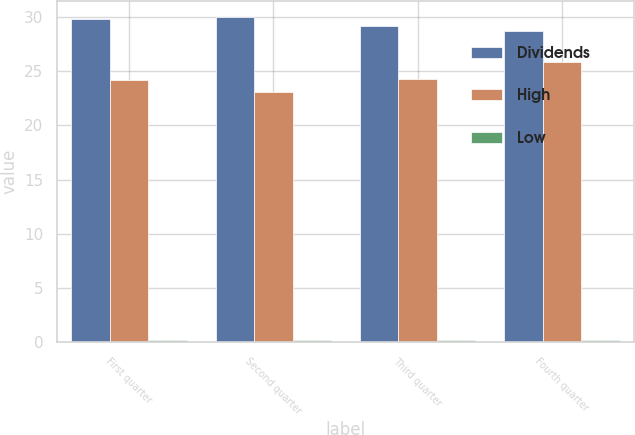<chart> <loc_0><loc_0><loc_500><loc_500><stacked_bar_chart><ecel><fcel>First quarter<fcel>Second quarter<fcel>Third quarter<fcel>Fourth quarter<nl><fcel>Dividends<fcel>29.84<fcel>29.96<fcel>29.2<fcel>28.71<nl><fcel>High<fcel>24.21<fcel>23.09<fcel>24.26<fcel>25.83<nl><fcel>Low<fcel>0.18<fcel>0.18<fcel>0.21<fcel>0.21<nl></chart> 